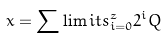<formula> <loc_0><loc_0><loc_500><loc_500>x = \sum \lim i t s _ { i = 0 } ^ { z } 2 ^ { i } Q</formula> 